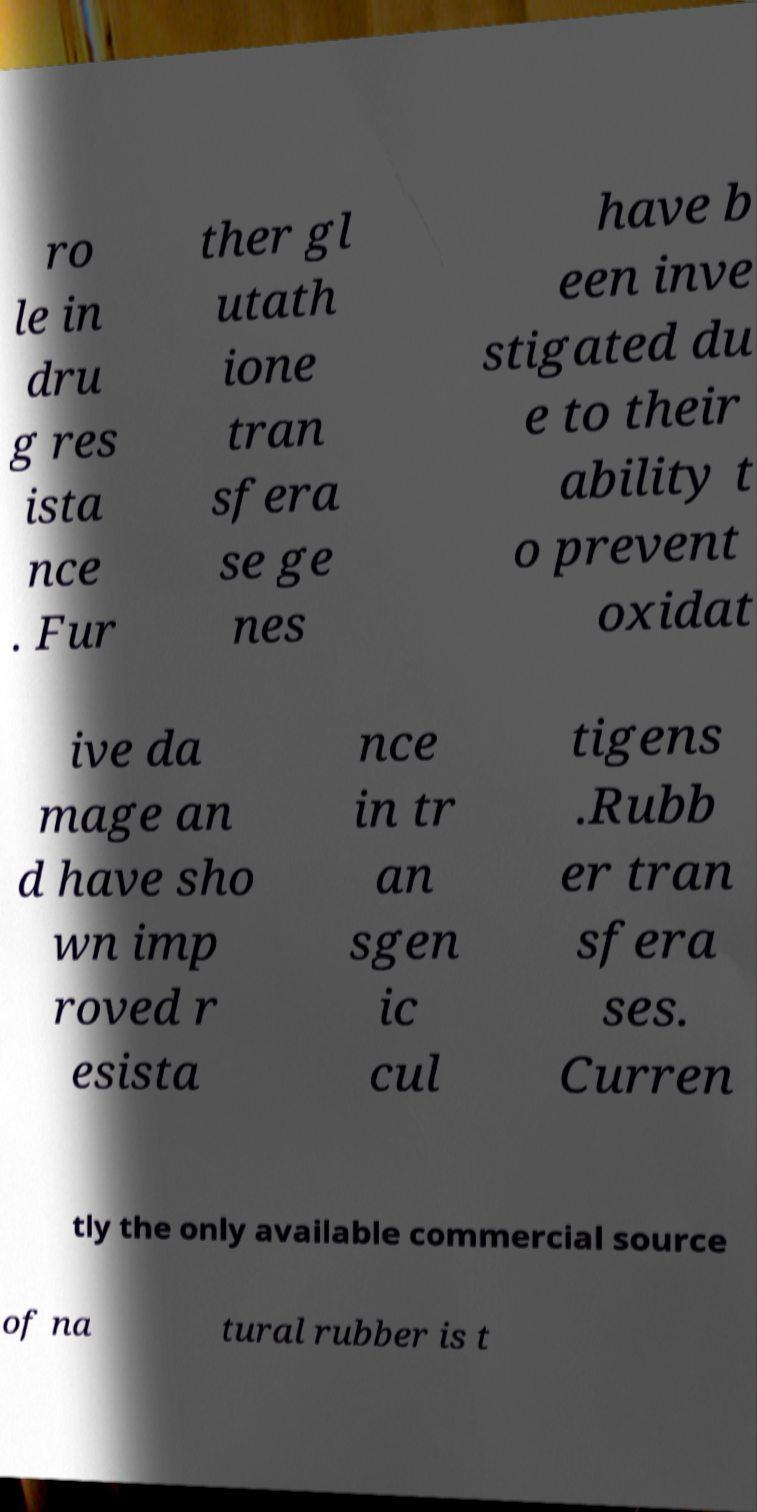Please read and relay the text visible in this image. What does it say? ro le in dru g res ista nce . Fur ther gl utath ione tran sfera se ge nes have b een inve stigated du e to their ability t o prevent oxidat ive da mage an d have sho wn imp roved r esista nce in tr an sgen ic cul tigens .Rubb er tran sfera ses. Curren tly the only available commercial source of na tural rubber is t 